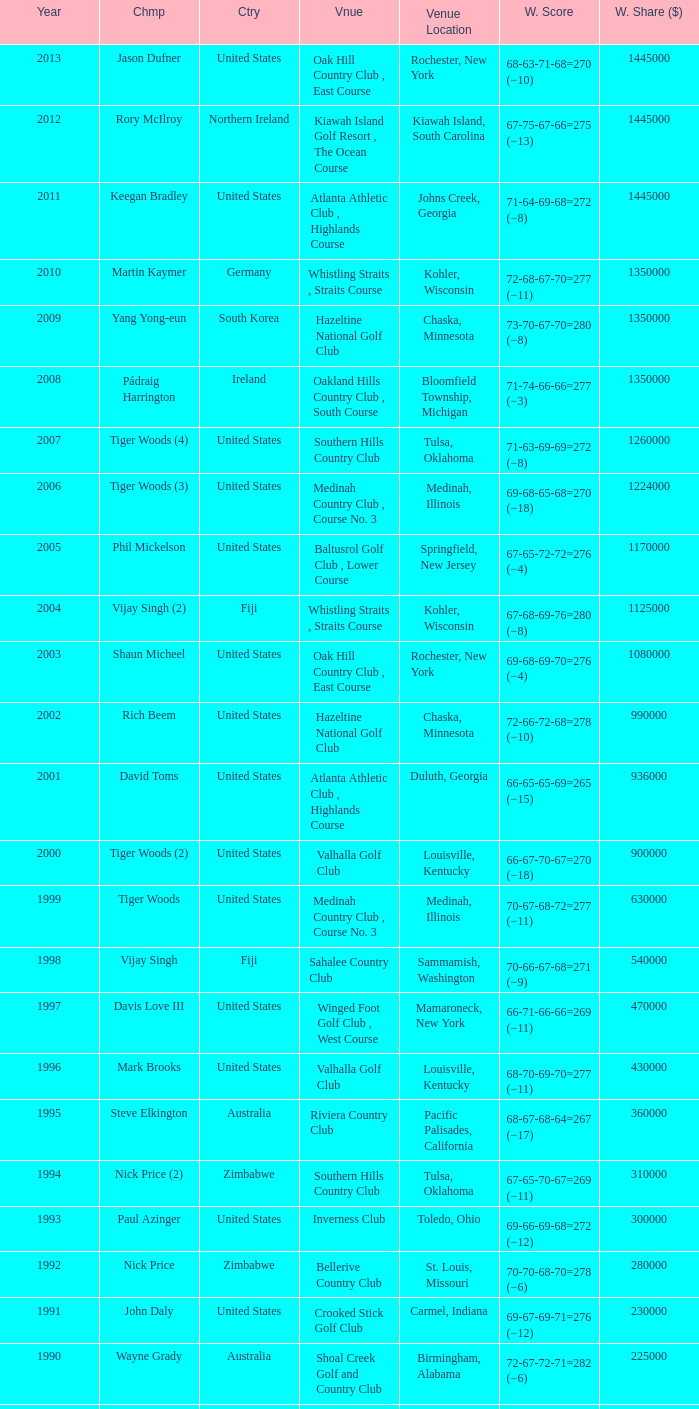Where is the Bellerive Country Club venue located? St. Louis, Missouri. 